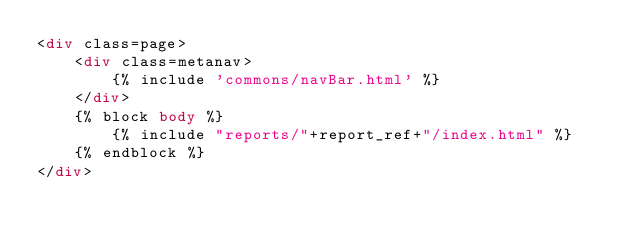<code> <loc_0><loc_0><loc_500><loc_500><_HTML_><div class=page>
    <div class=metanav>
        {% include 'commons/navBar.html' %}
    </div>
    {% block body %}
        {% include "reports/"+report_ref+"/index.html" %}
    {% endblock %}
</div></code> 